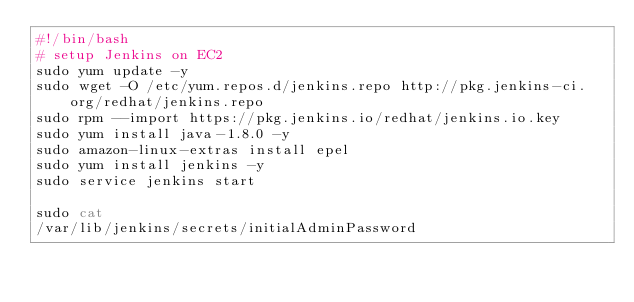Convert code to text. <code><loc_0><loc_0><loc_500><loc_500><_Bash_>#!/bin/bash
# setup Jenkins on EC2
sudo yum update -y
sudo wget -O /etc/yum.repos.d/jenkins.repo http://pkg.jenkins-ci.org/redhat/jenkins.repo
sudo rpm --import https://pkg.jenkins.io/redhat/jenkins.io.key
sudo yum install java-1.8.0 -y
sudo amazon-linux-extras install epel
sudo yum install jenkins -y
sudo service jenkins start

sudo cat
/var/lib/jenkins/secrets/initialAdminPassword</code> 